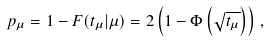Convert formula to latex. <formula><loc_0><loc_0><loc_500><loc_500>p _ { \mu } = 1 - F ( t _ { \mu } | \mu ) = 2 \left ( 1 - \Phi \left ( \sqrt { t _ { \mu } } \right ) \right ) \, ,</formula> 